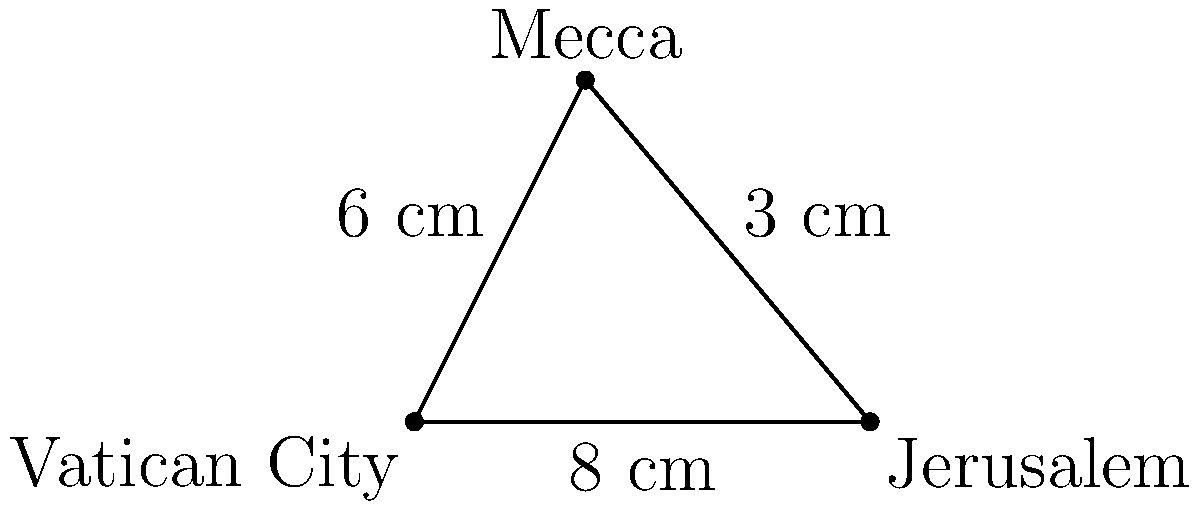On a flat map projection, Vatican City, Jerusalem, and Mecca form a right-angled triangle. The distance between Vatican City and Jerusalem is 8 cm, and the distance between Jerusalem and Mecca is 3 cm. If the distance between Vatican City and Mecca is 6 cm, calculate the error in the map projection (to the nearest 0.1 cm) caused by representing the Earth's curved surface on a flat plane. To solve this problem, we'll use the Pythagorean theorem and compare the calculated distance with the given distance:

1) Let's define our triangle:
   - Vatican City to Jerusalem: 8 cm (base)
   - Jerusalem to Mecca: 3 cm (height)
   - Vatican City to Mecca: 6 cm (hypotenuse)

2) According to the Pythagorean theorem:
   $a^2 + b^2 = c^2$
   Where $c$ is the hypotenuse, and $a$ and $b$ are the other two sides.

3) Let's calculate the expected hypotenuse:
   $c^2 = 8^2 + 3^2$
   $c^2 = 64 + 9 = 73$
   $c = \sqrt{73} \approx 8.544$ cm

4) The map shows the distance as 6 cm, so let's calculate the error:
   Error = Calculated distance - Given distance
   Error = $8.544 - 6 = 2.544$ cm

5) Rounding to the nearest 0.1 cm:
   Error ≈ 2.5 cm

This error represents the distortion caused by projecting the Earth's curved surface onto a flat map.
Answer: 2.5 cm 